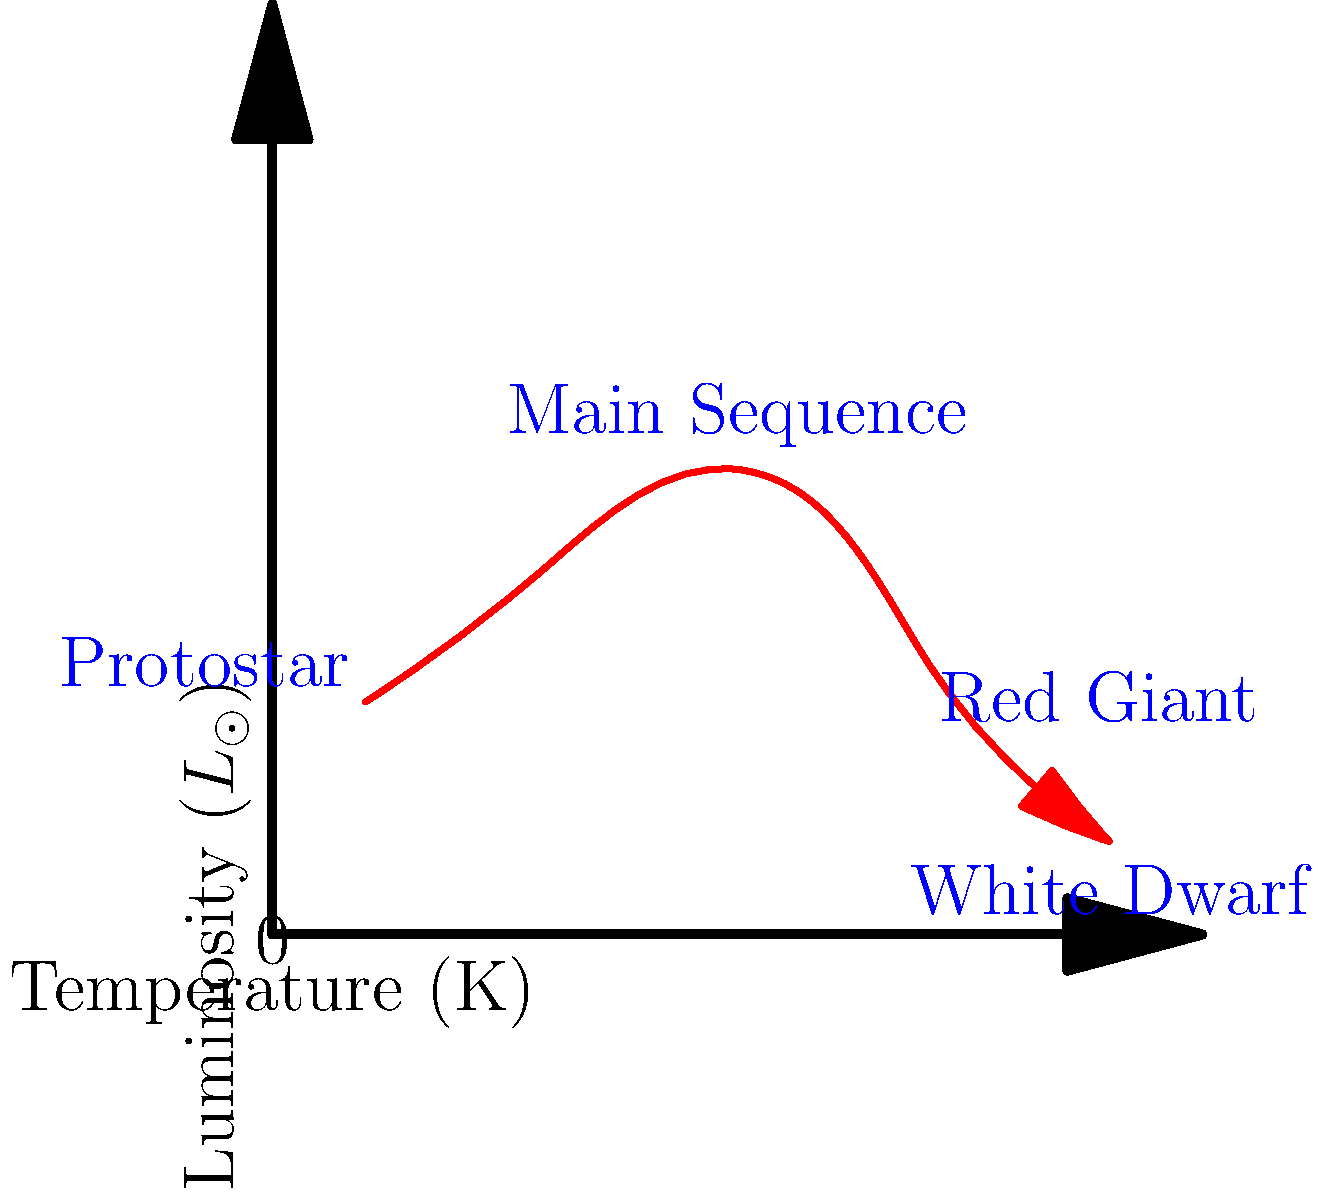As someone who manages inventory and understands product lifecycles, consider the Hertzsprung-Russell diagram shown above. Which stage of a star's life cycle is characterized by the highest luminosity and coolest temperature? To answer this question, let's analyze the Hertzsprung-Russell diagram step-by-step:

1. The x-axis represents temperature, with higher temperatures to the left and lower temperatures to the right.
2. The y-axis represents luminosity, with higher luminosity at the top and lower luminosity at the bottom.
3. The red arrow shows the typical life cycle of a star, starting from the bottom left and moving through various stages.
4. The main stages labeled on the diagram are:
   a) Protostar (bottom left)
   b) Main Sequence (middle)
   c) Red Giant (top right)
   d) White Dwarf (bottom right)

5. To find the stage with the highest luminosity and coolest temperature, we need to look for the point that is highest on the y-axis (luminosity) and furthest right on the x-axis (coolest temperature).

6. The Red Giant stage clearly meets these criteria, as it is positioned at the top right of the diagram.

This stage is similar to how, in your grocery store, some products might have a "peak season" where they are abundant (high luminosity) but also need to be kept cool (lower temperature) to maintain freshness.
Answer: Red Giant 